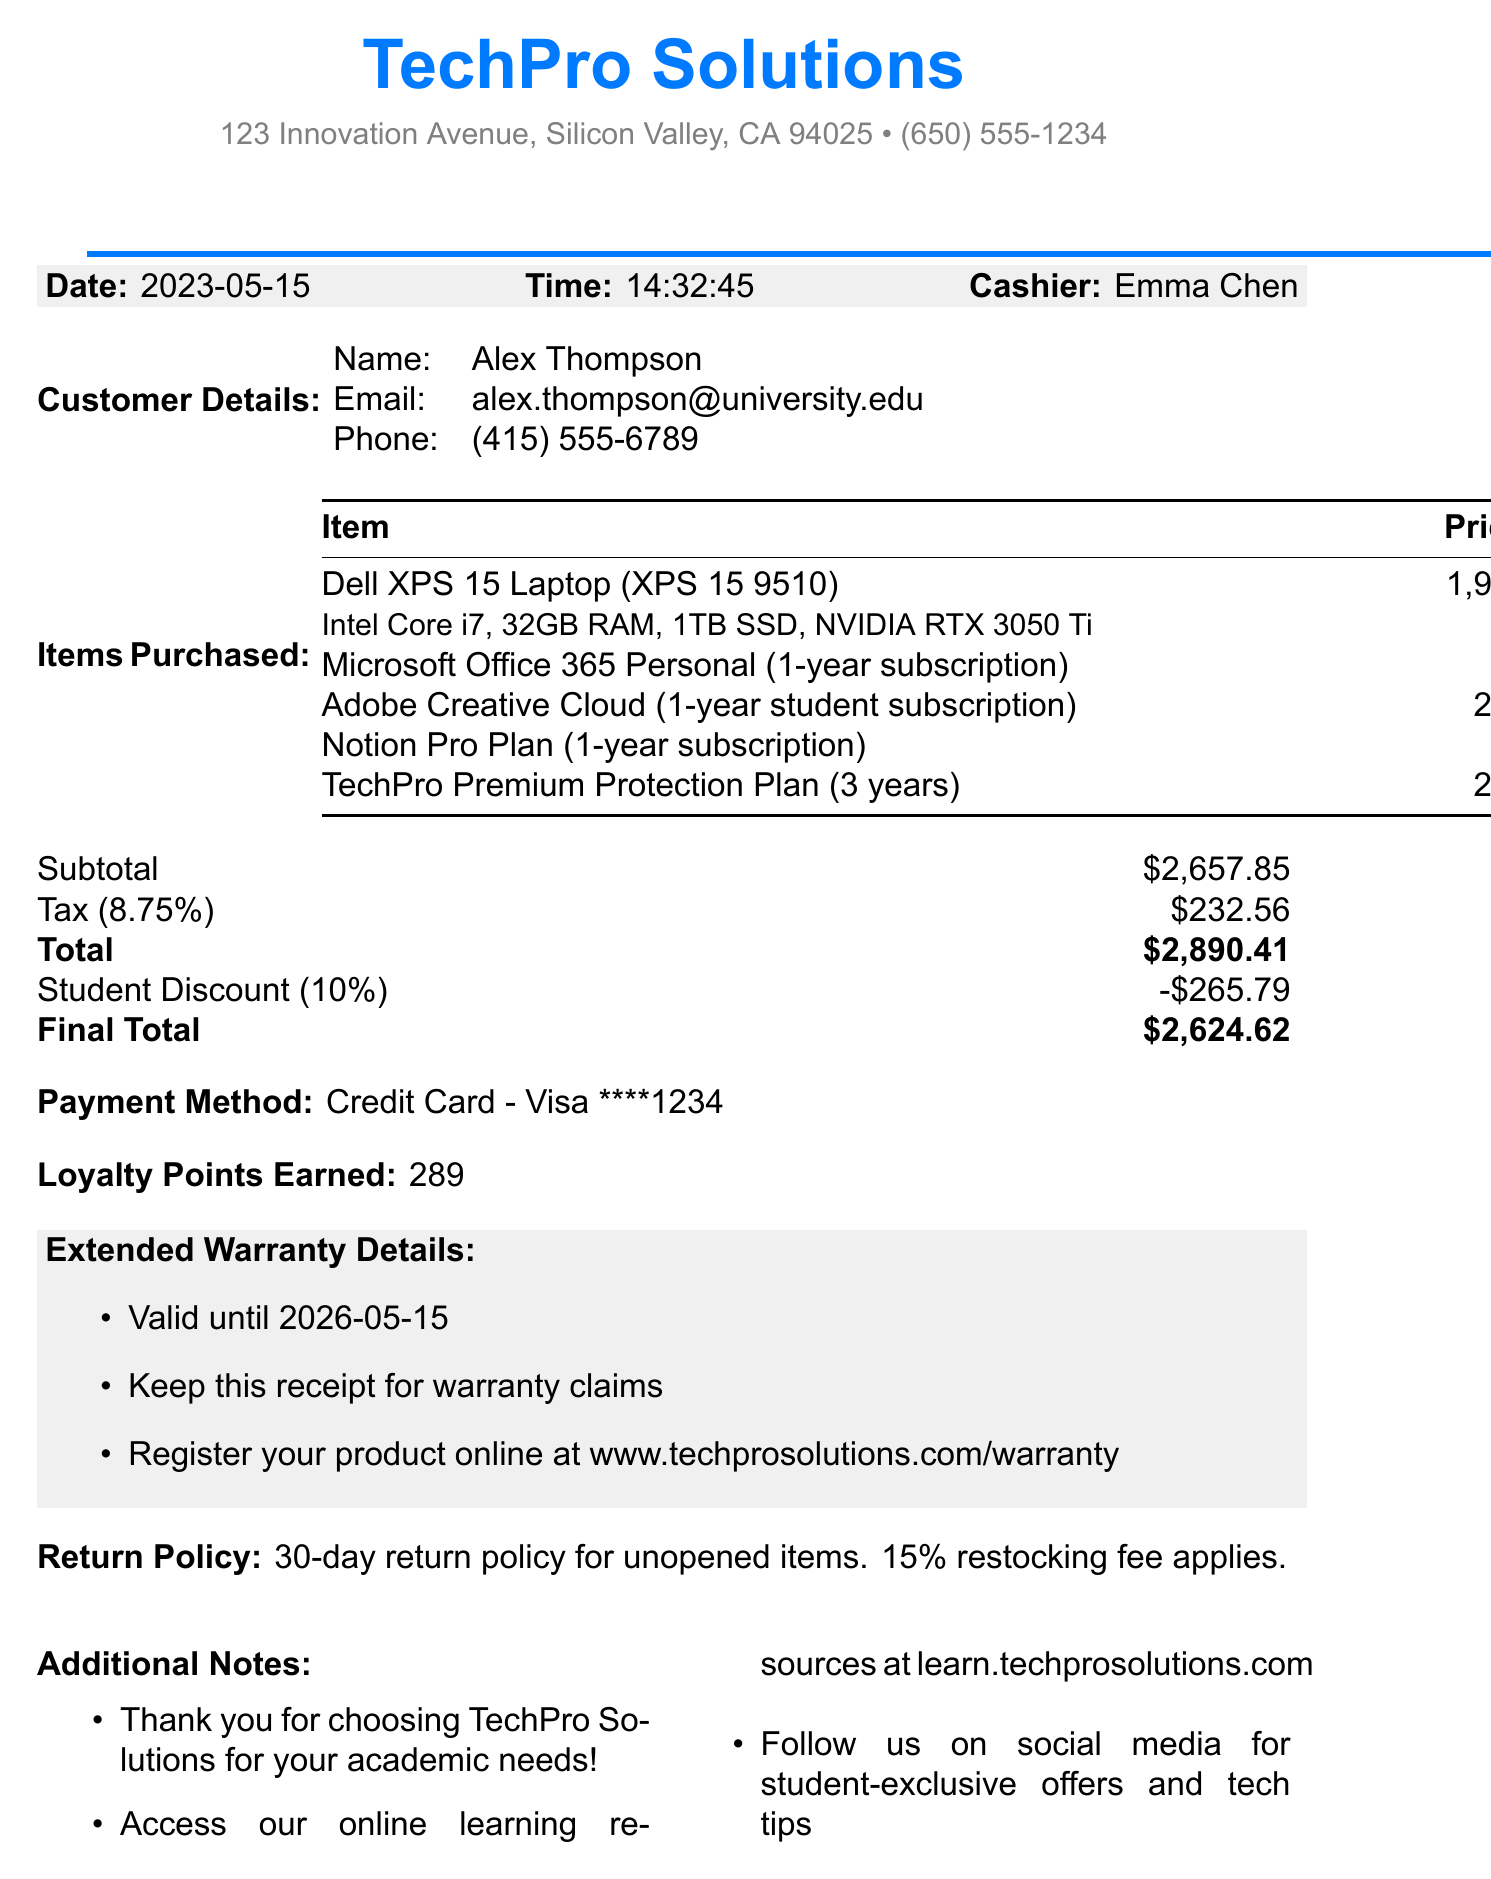what is the name of the store? The store name is listed at the top of the receipt as TechPro Solutions.
Answer: TechPro Solutions who was the cashier at the time of purchase? The receipt specifies that Emma Chen was the cashier.
Answer: Emma Chen what is the total amount after applying the student discount? The final total after the discount is shown as $2,624.62.
Answer: $2,624.62 how much was spent on the laptop? The document indicates the price of the Dell XPS 15 Laptop as $1,999.99.
Answer: $1,999.99 when does the extended warranty expire? The warranty details mention that it is valid until 2026-05-15.
Answer: 2026-05-15 what percentage was saved due to the student discount? The student discount is noted as 10%, which is a standard amount for student discounts.
Answer: 10% how many loyalty points were earned from this purchase? The total loyalty points earned are stated as 289.
Answer: 289 what is the return policy for unopened items? The return policy mentions that there’s a 30-day return policy with a 15% restocking fee.
Answer: 30-day return policy, 15% restocking fee which product had the highest cost? From the itemized list, the Dell XPS 15 Laptop is the most expensive item.
Answer: Dell XPS 15 Laptop 